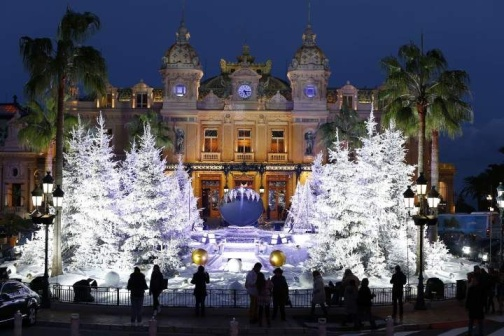Create a fictional story based on this scene. In a distant land where magic meets reality, a grand celebration is held annually at the majestic palace seen in the image. This year, a young orphan named Elara, who loved watching the palace from afar, was invited by a mysterious figure. The fountain, lit with magical Christmas lights, was said to grant a wish to someone pure of heart. As Elara approached the fountain, the twinkling lights seemed to dance to a silent melody, and the water began to swirl. Her one wish was to find a family who loved her. At that moment, a warm light enveloped her, and when it faded, she saw a loving family waiting for her beside the palm trees. The palace continued to glow, blessing her with a family and rewriting her destiny. 